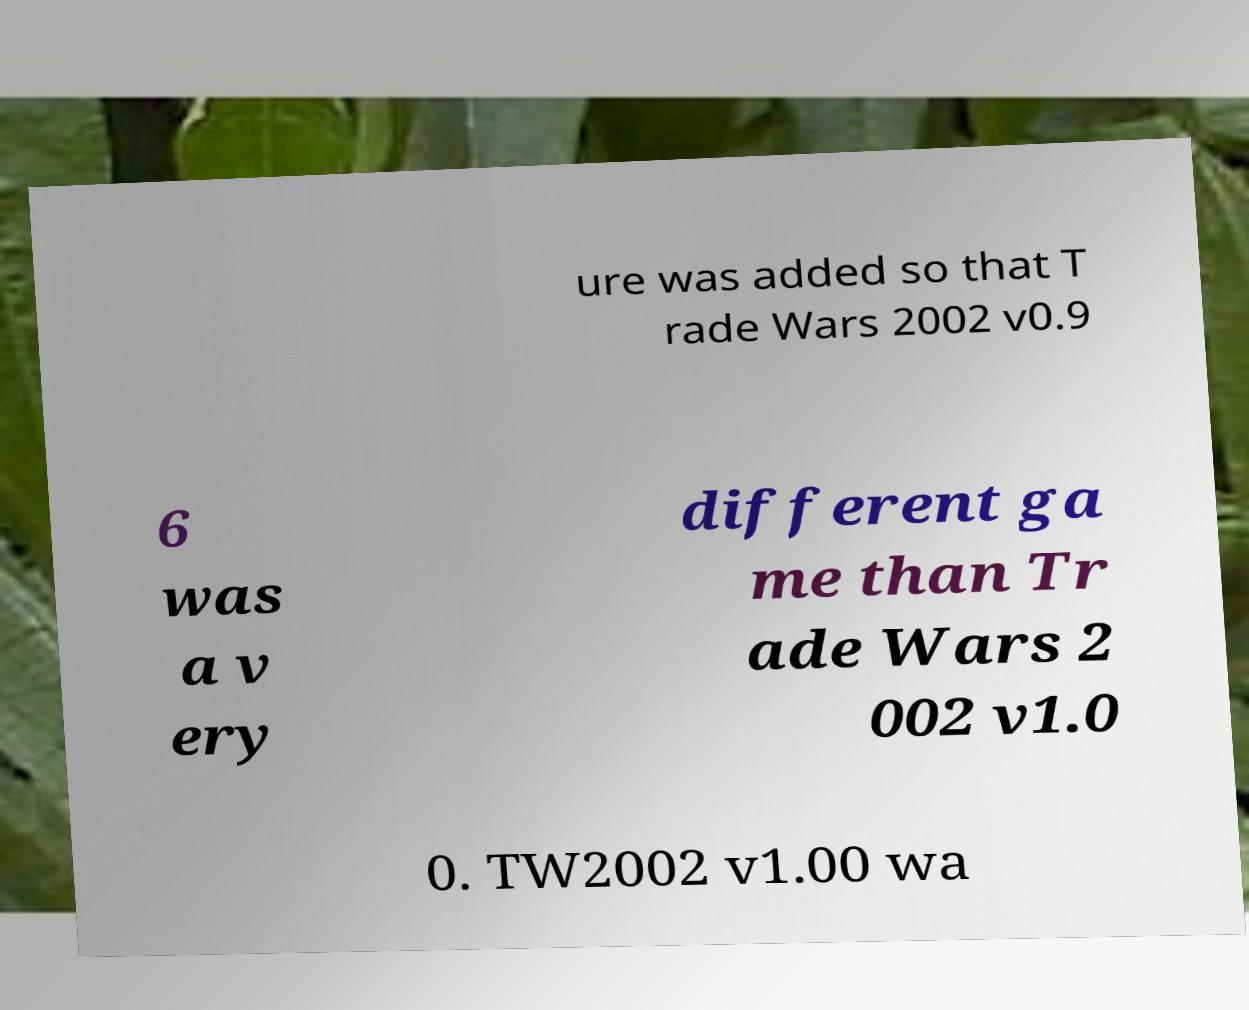I need the written content from this picture converted into text. Can you do that? ure was added so that T rade Wars 2002 v0.9 6 was a v ery different ga me than Tr ade Wars 2 002 v1.0 0. TW2002 v1.00 wa 